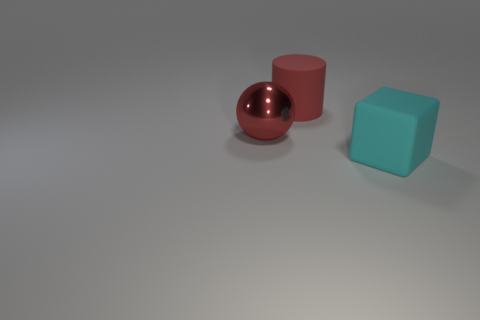What number of objects are either large cyan cylinders or matte objects behind the cube?
Offer a terse response. 1. There is a object that is the same color as the matte cylinder; what is its shape?
Offer a terse response. Sphere. How many red spheres have the same size as the cyan block?
Keep it short and to the point. 1. How many gray objects are either balls or rubber cubes?
Your answer should be compact. 0. The matte thing that is to the right of the big red thing that is to the right of the metallic object is what shape?
Ensure brevity in your answer.  Cube. There is a cyan object that is the same size as the red sphere; what is its shape?
Offer a very short reply. Cube. Are there any objects that have the same color as the metal ball?
Ensure brevity in your answer.  Yes. Are there an equal number of large metal objects on the right side of the matte cylinder and big objects behind the red ball?
Ensure brevity in your answer.  No. What number of other things are made of the same material as the red cylinder?
Your answer should be very brief. 1. There is a cylinder; are there any red objects left of it?
Provide a short and direct response. Yes. 